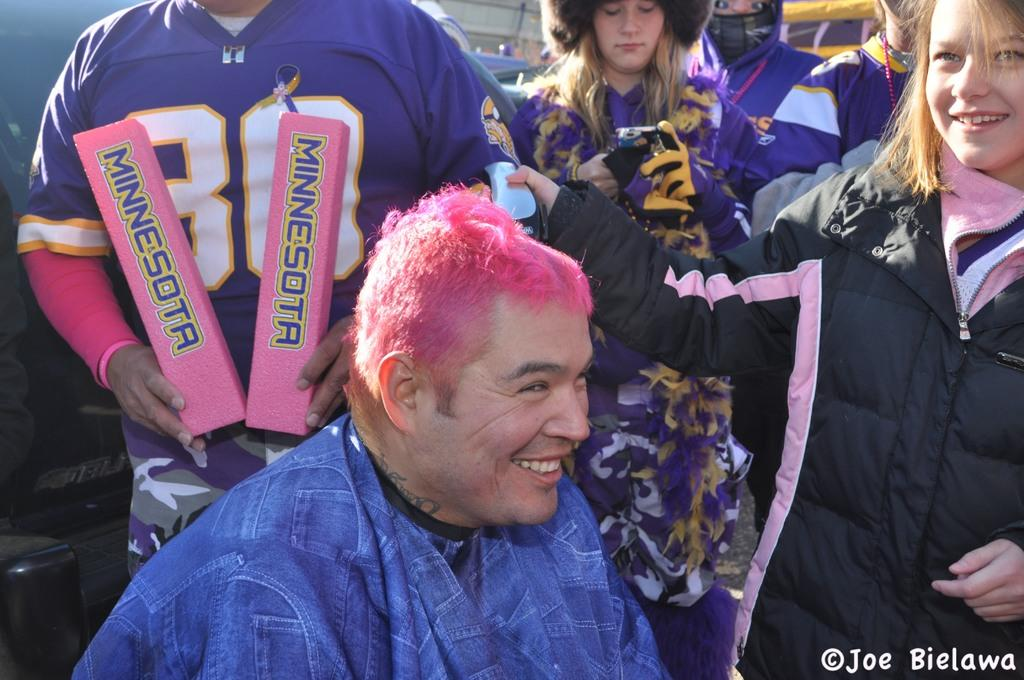Provide a one-sentence caption for the provided image. Pink haired heavy set Minnesota fan smiling as a girl gives him a buzz cut. 